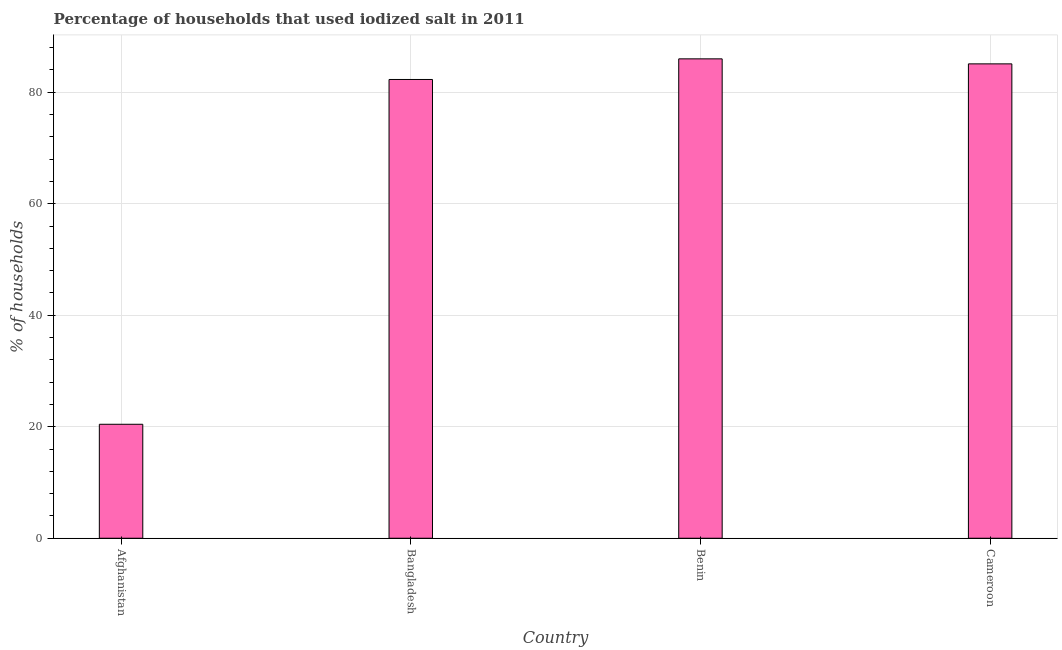Does the graph contain any zero values?
Offer a very short reply. No. Does the graph contain grids?
Your answer should be compact. Yes. What is the title of the graph?
Your response must be concise. Percentage of households that used iodized salt in 2011. What is the label or title of the X-axis?
Provide a succinct answer. Country. What is the label or title of the Y-axis?
Your answer should be compact. % of households. What is the percentage of households where iodized salt is consumed in Benin?
Keep it short and to the point. 86. Across all countries, what is the minimum percentage of households where iodized salt is consumed?
Ensure brevity in your answer.  20.45. In which country was the percentage of households where iodized salt is consumed maximum?
Offer a very short reply. Benin. In which country was the percentage of households where iodized salt is consumed minimum?
Make the answer very short. Afghanistan. What is the sum of the percentage of households where iodized salt is consumed?
Your answer should be compact. 273.85. What is the difference between the percentage of households where iodized salt is consumed in Afghanistan and Benin?
Offer a terse response. -65.55. What is the average percentage of households where iodized salt is consumed per country?
Ensure brevity in your answer.  68.46. What is the median percentage of households where iodized salt is consumed?
Keep it short and to the point. 83.7. In how many countries, is the percentage of households where iodized salt is consumed greater than 44 %?
Make the answer very short. 3. Is the difference between the percentage of households where iodized salt is consumed in Bangladesh and Benin greater than the difference between any two countries?
Offer a terse response. No. What is the difference between the highest and the second highest percentage of households where iodized salt is consumed?
Provide a succinct answer. 0.9. What is the difference between the highest and the lowest percentage of households where iodized salt is consumed?
Your response must be concise. 65.55. Are the values on the major ticks of Y-axis written in scientific E-notation?
Offer a terse response. No. What is the % of households in Afghanistan?
Your answer should be very brief. 20.45. What is the % of households of Bangladesh?
Make the answer very short. 82.3. What is the % of households in Cameroon?
Provide a succinct answer. 85.1. What is the difference between the % of households in Afghanistan and Bangladesh?
Provide a short and direct response. -61.85. What is the difference between the % of households in Afghanistan and Benin?
Ensure brevity in your answer.  -65.55. What is the difference between the % of households in Afghanistan and Cameroon?
Your answer should be compact. -64.65. What is the difference between the % of households in Bangladesh and Benin?
Your answer should be very brief. -3.7. What is the difference between the % of households in Bangladesh and Cameroon?
Offer a terse response. -2.8. What is the ratio of the % of households in Afghanistan to that in Bangladesh?
Your response must be concise. 0.25. What is the ratio of the % of households in Afghanistan to that in Benin?
Provide a short and direct response. 0.24. What is the ratio of the % of households in Afghanistan to that in Cameroon?
Provide a short and direct response. 0.24. What is the ratio of the % of households in Bangladesh to that in Benin?
Make the answer very short. 0.96. What is the ratio of the % of households in Bangladesh to that in Cameroon?
Your answer should be very brief. 0.97. 